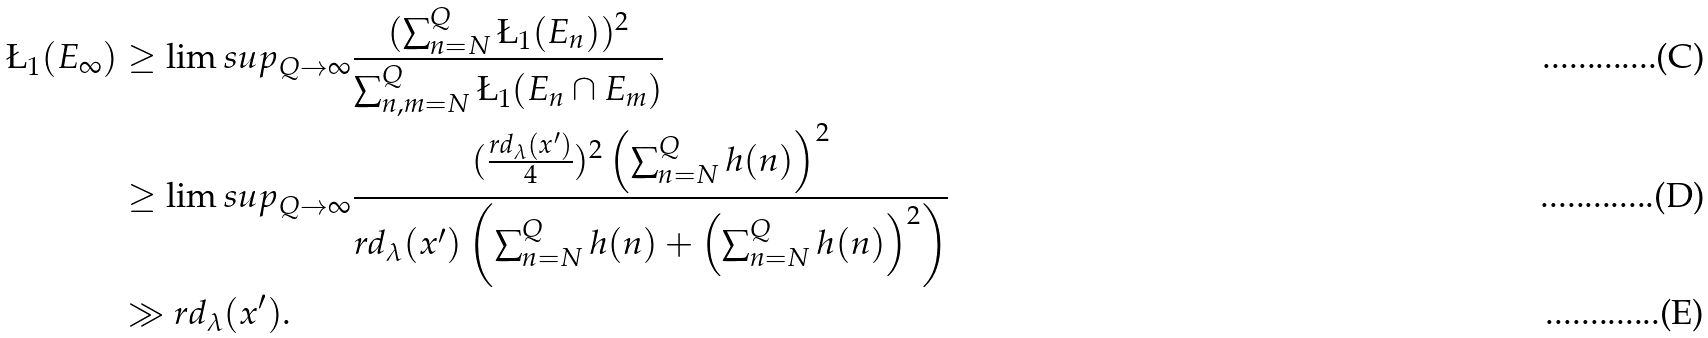<formula> <loc_0><loc_0><loc_500><loc_500>\L _ { 1 } ( E _ { \infty } ) & \geq \lim s u p _ { Q \to \infty } \frac { ( \sum _ { n = N } ^ { Q } \L _ { 1 } ( E _ { n } ) ) ^ { 2 } } { \sum _ { n , m = N } ^ { Q } \L _ { 1 } ( E _ { n } \cap E _ { m } ) } \\ & \geq \lim s u p _ { Q \to \infty } \frac { ( \frac { r d _ { \lambda } ( x ^ { \prime } ) } { 4 } ) ^ { 2 } \left ( \sum _ { n = N } ^ { Q } h ( n ) \right ) ^ { 2 } } { r d _ { \lambda } ( x ^ { \prime } ) \left ( \sum _ { n = N } ^ { Q } h ( n ) + \left ( \sum _ { n = N } ^ { Q } h ( n ) \right ) ^ { 2 } \right ) } \\ & \gg r d _ { \lambda } ( x ^ { \prime } ) .</formula> 